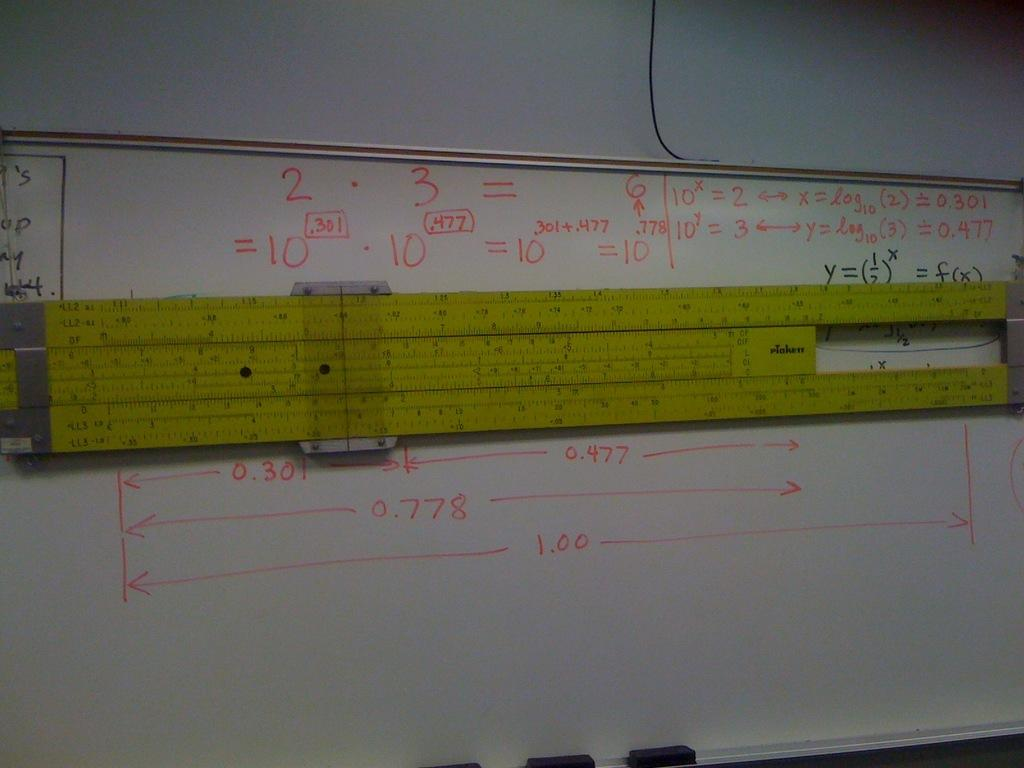<image>
Describe the image concisely. a white board with a slide ruler and numbers like 2 and 3 